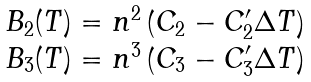<formula> <loc_0><loc_0><loc_500><loc_500>\begin{array} { l } B _ { 2 } ( T ) = n ^ { 2 } \left ( C _ { 2 } - C _ { 2 } ^ { \prime } \Delta T \right ) \\ B _ { 3 } ( T ) = n ^ { 3 } \left ( C _ { 3 } - C _ { 3 } ^ { \prime } \Delta T \right ) \end{array}</formula> 